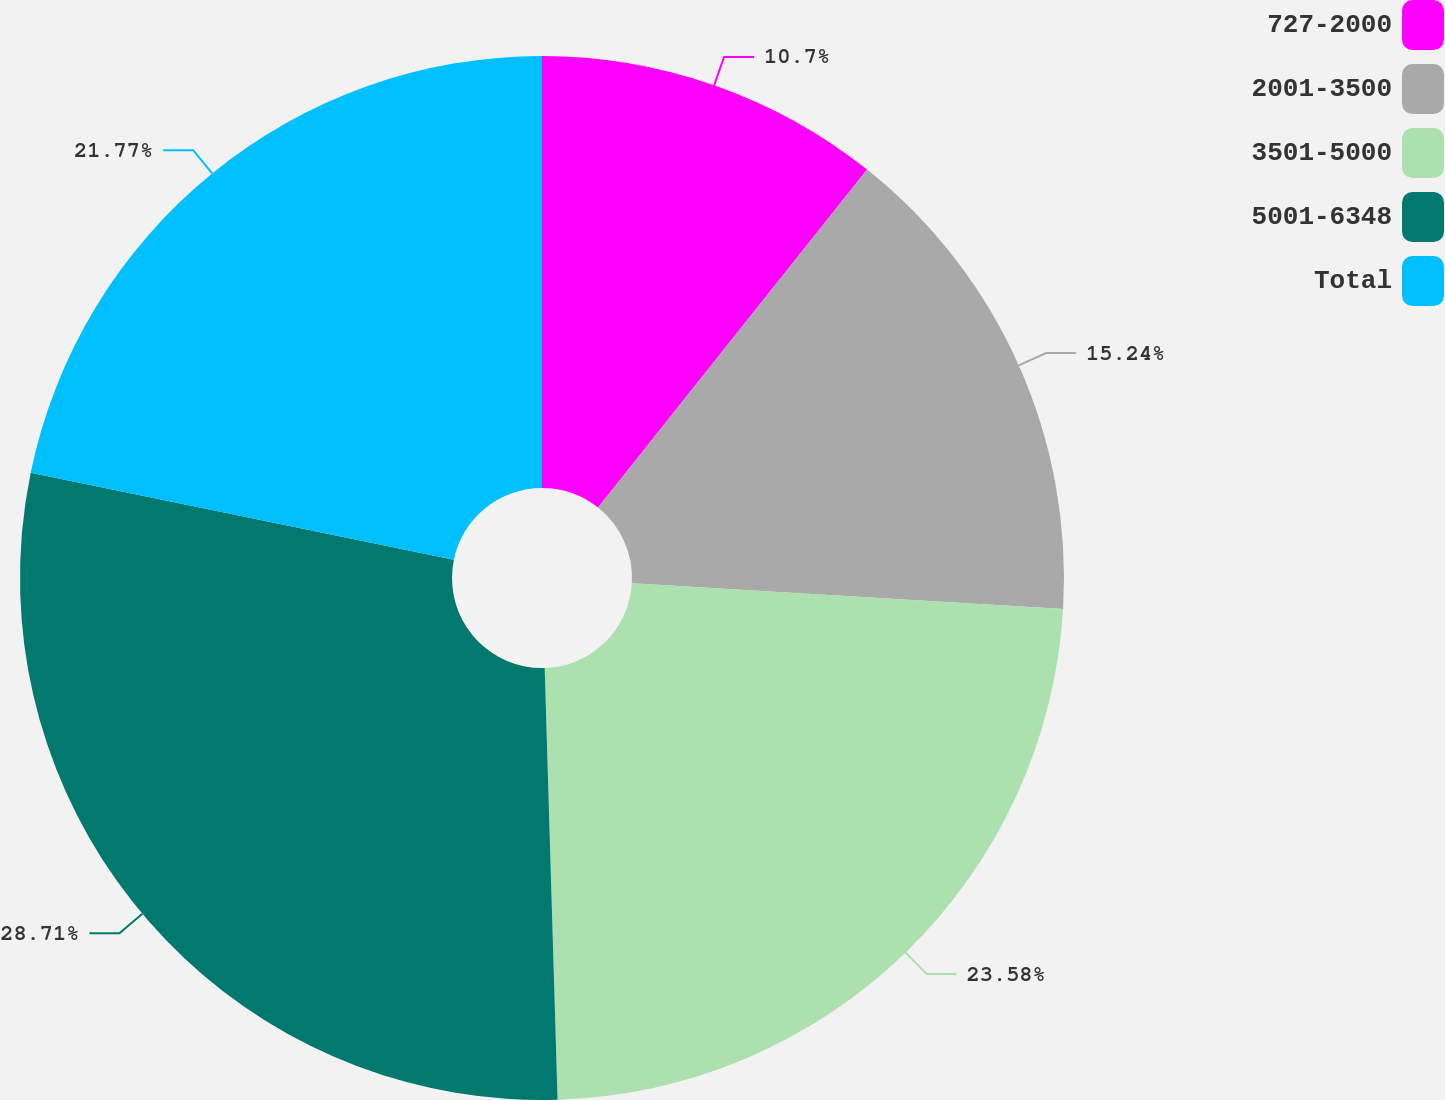Convert chart. <chart><loc_0><loc_0><loc_500><loc_500><pie_chart><fcel>727-2000<fcel>2001-3500<fcel>3501-5000<fcel>5001-6348<fcel>Total<nl><fcel>10.7%<fcel>15.24%<fcel>23.58%<fcel>28.7%<fcel>21.77%<nl></chart> 